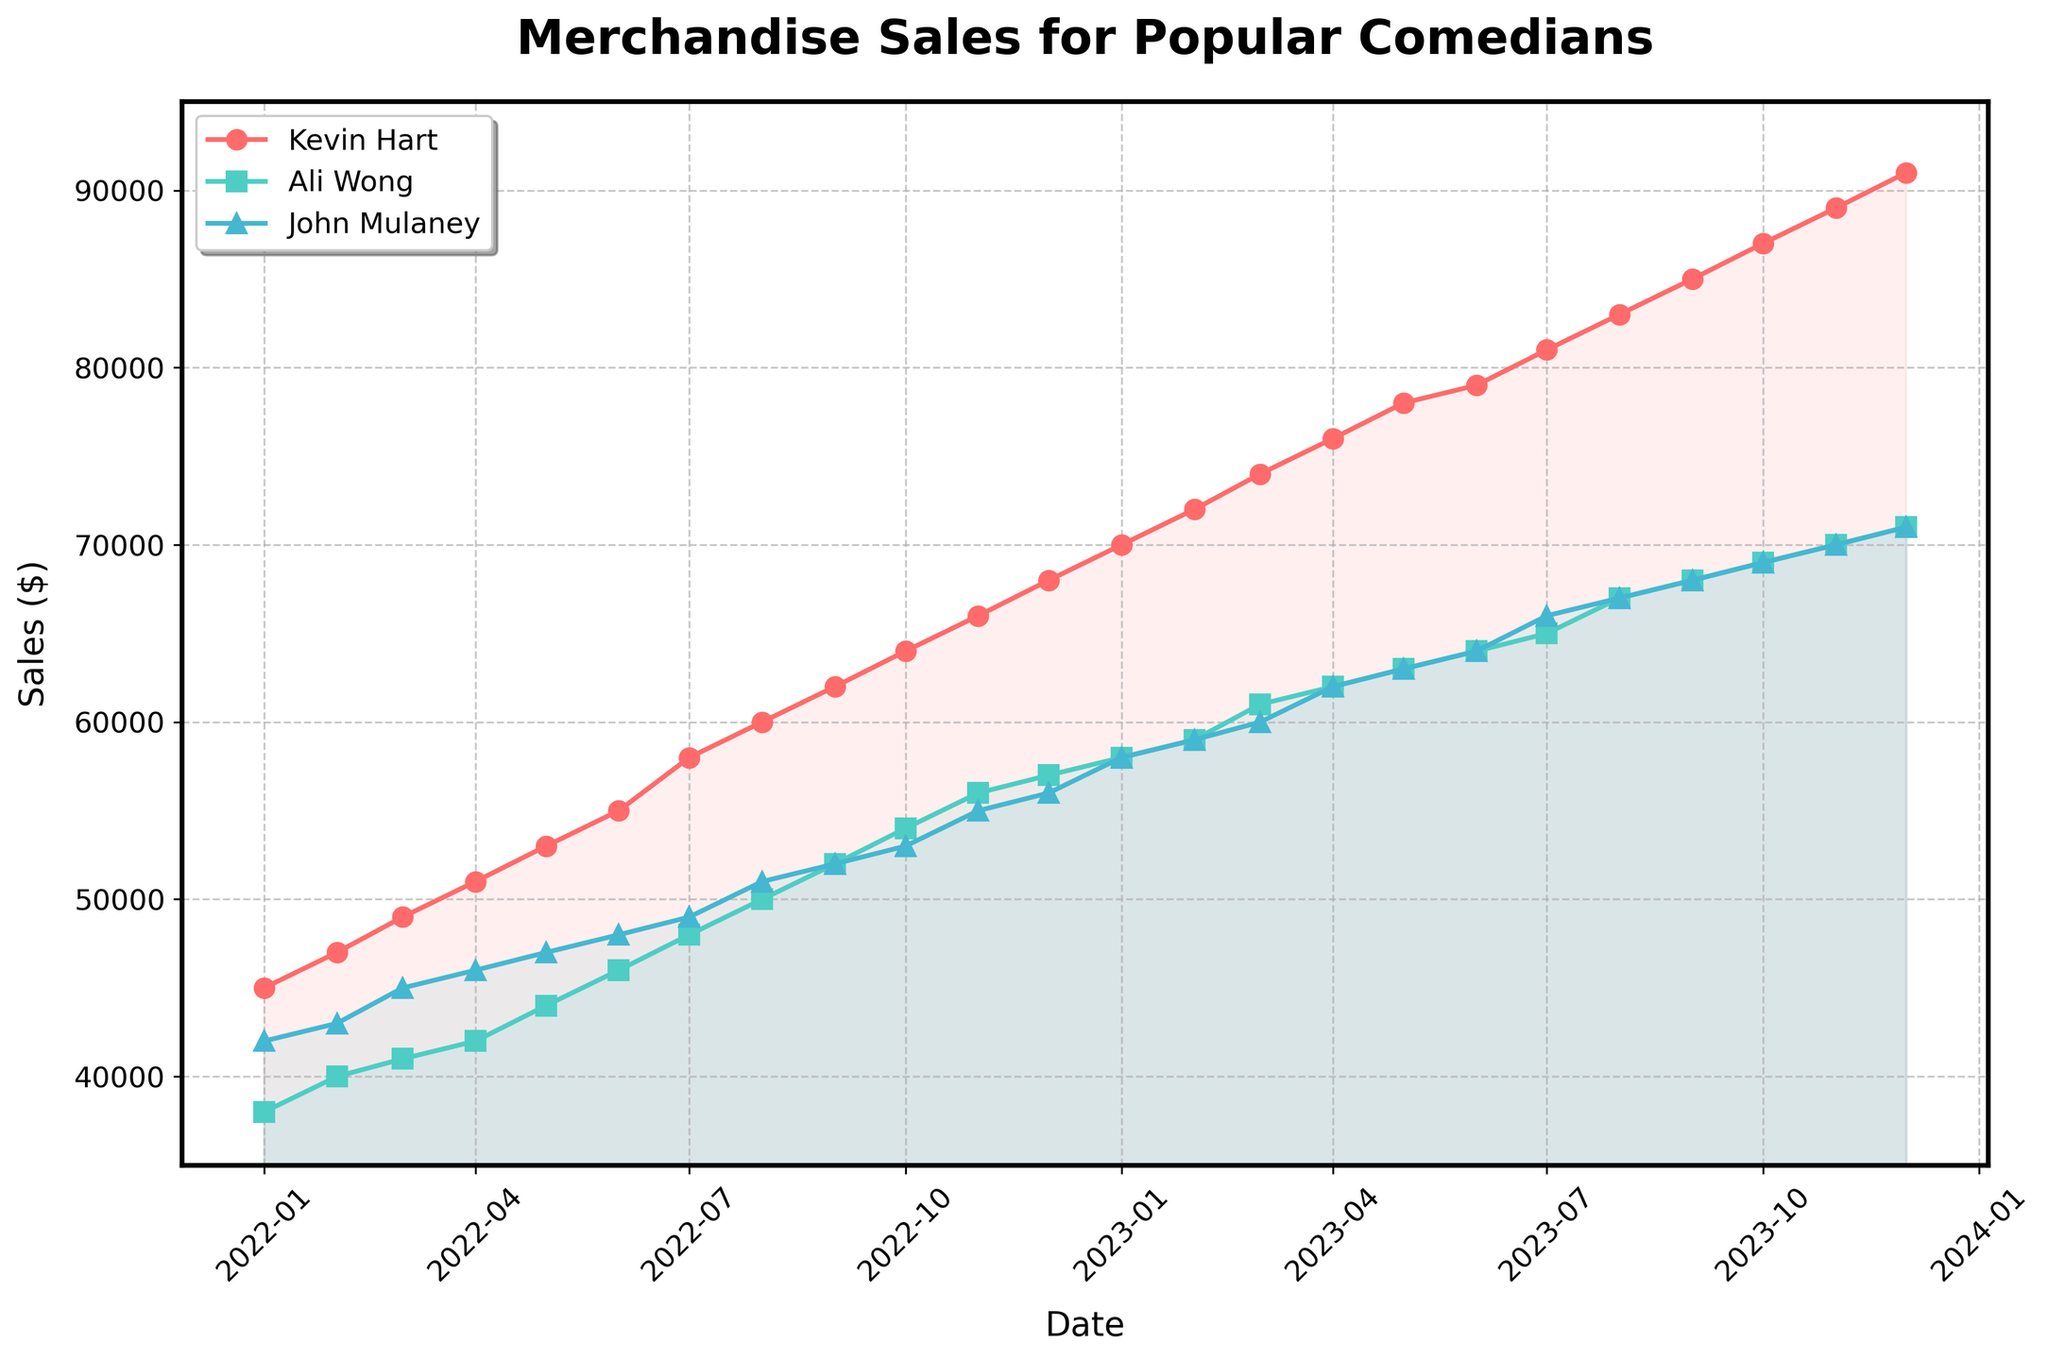What is the title of the plot? The title of the plot is visually located at the top and usually provides a succinct overview of what the data represents. In this case, it states 'Merchandise Sales for Popular Comedians'.
Answer: Merchandise Sales for Popular Comedians What are the data points for Kevin Hart and John Mulaney on January 1, 2023? To find the data points, look at the plot markers for Kevin Hart and John Mulaney on the date January 1, 2023, then refer to the y-axis for their respective values. Kevin Hart's marker aligns with 70,000, and John Mulaney's with 58,000.
Answer: Kevin Hart: 70,000, John Mulaney: 58,000 How does the sales trend of Ali Wong compare to Kevin Hart from January 1, 2022, to December 1, 2023? Compare the trend lines associated with Ali Wong and Kevin Hart from the start to the end of the plot. Ali Wong's sales consistently increase but at a slower rate compared to Kevin Hart, who shows a steep rise over time.
Answer: Kevin Hart's sales increased more rapidly In which month did Ali Wong's sales surpass 60,000 for the first time? Identify the point where Ali Wong's sales line crosses the 60,000 mark on the y-axis. This happens around March 1, 2023.
Answer: March 1, 2023 What is the average sales value for John Mulaney in the first quarter of 2023? Average requires summing the values for January, February, and March 2023 for John Mulaney and dividing by 3: (58,000 + 59,000 + 60,000) / 3 = 59,000.
Answer: 59,000 Which comedian had the highest merchandise sales in July 2022? On the July 2022 marker, first check Kevin Hart, Ali Wong, and John Mulaney's sales values. Kevin Hart's value is highest at 58,000.
Answer: Kevin Hart Did any of the comedians’ sales ever decline during the period shown in the plot? Examine each comedian's sales trajectory over time for any downward slopes. None of the comedians show a sales decline during this period; all trends are upward.
Answer: No, sales only increased What are the highest and lowest sales numbers achieved by Ali Wong throughout the period? Locate the peak and the starting value of Ali Wong's sales line. Ali Wong starts at 38,000 in January 2022 and reaches the highest value of 71,000 in December 2023.
Answer: Highest: 71,000, Lowest: 38,000 How does the sales increase of John Mulaney in the last six months of 2023 compare to his increase in the same period of 2022? Calculate the increase for both periods: 
Last half of 2023: 70,000 (Dec 2023) - 64,000 (Jun 2023) = 6,000  
Last half of 2022: 60,000 (Dec 2022) - 43,000 (Jun 2022) = 17,000  
John Mulaney's increase was higher in the same period of 2022.
Answer: Higher in 2022 Which comedian showed the most consistent increase in sales over the entire period? Look at the overall slope and smoothness of the lines. Kevin Hart's and Ali Wong's sales show a steady increase, but Kevin Hart's increase is slightly more uniform without significant fluctuations.
Answer: Kevin Hart 